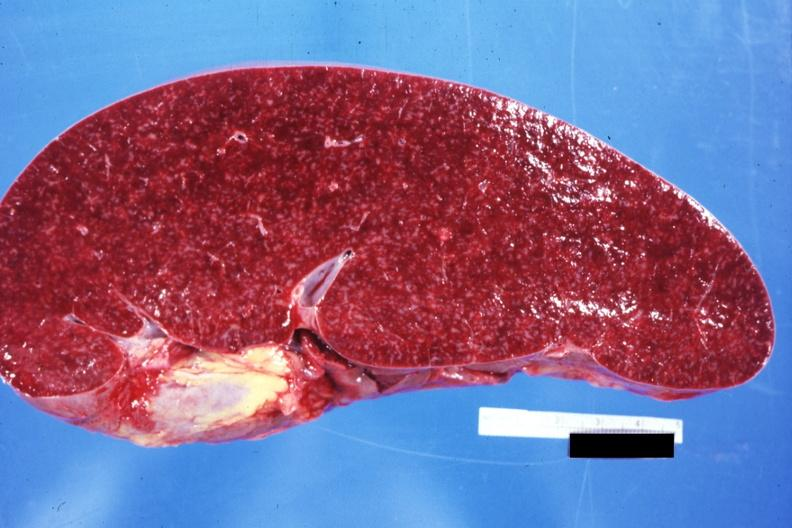does von see other sides this case?
Answer the question using a single word or phrase. No 